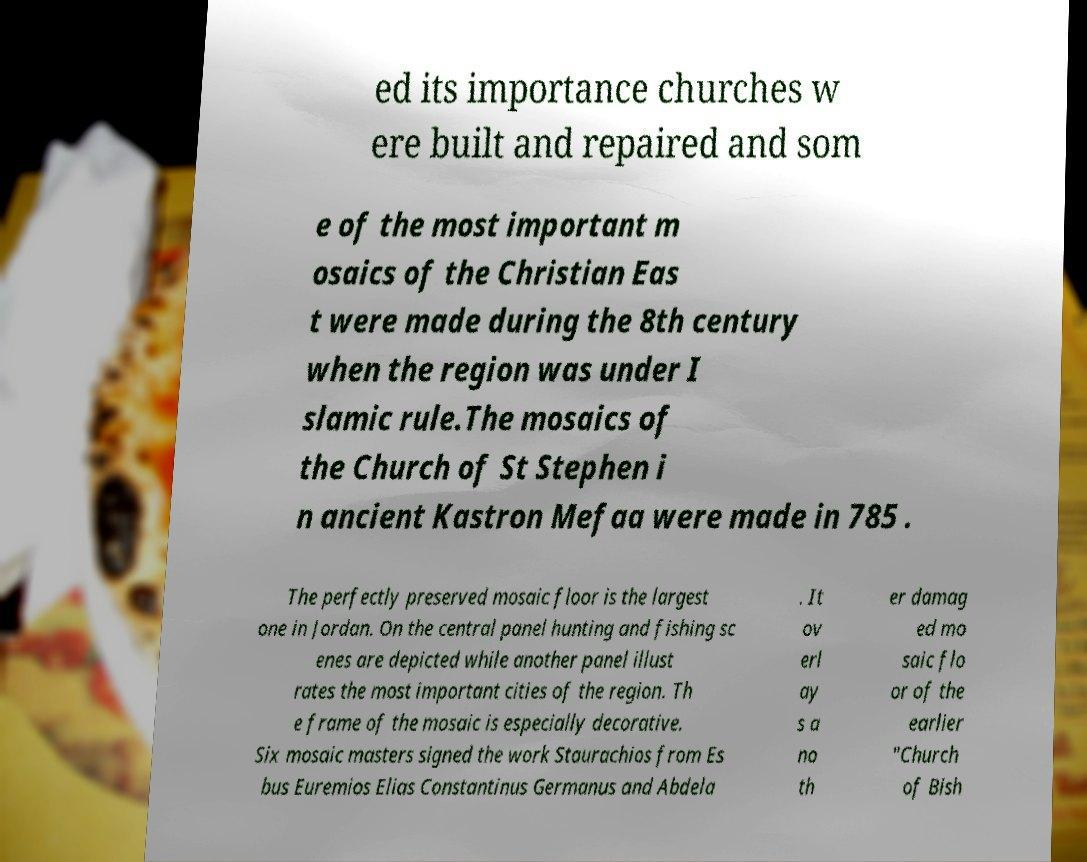Could you assist in decoding the text presented in this image and type it out clearly? ed its importance churches w ere built and repaired and som e of the most important m osaics of the Christian Eas t were made during the 8th century when the region was under I slamic rule.The mosaics of the Church of St Stephen i n ancient Kastron Mefaa were made in 785 . The perfectly preserved mosaic floor is the largest one in Jordan. On the central panel hunting and fishing sc enes are depicted while another panel illust rates the most important cities of the region. Th e frame of the mosaic is especially decorative. Six mosaic masters signed the work Staurachios from Es bus Euremios Elias Constantinus Germanus and Abdela . It ov erl ay s a no th er damag ed mo saic flo or of the earlier "Church of Bish 